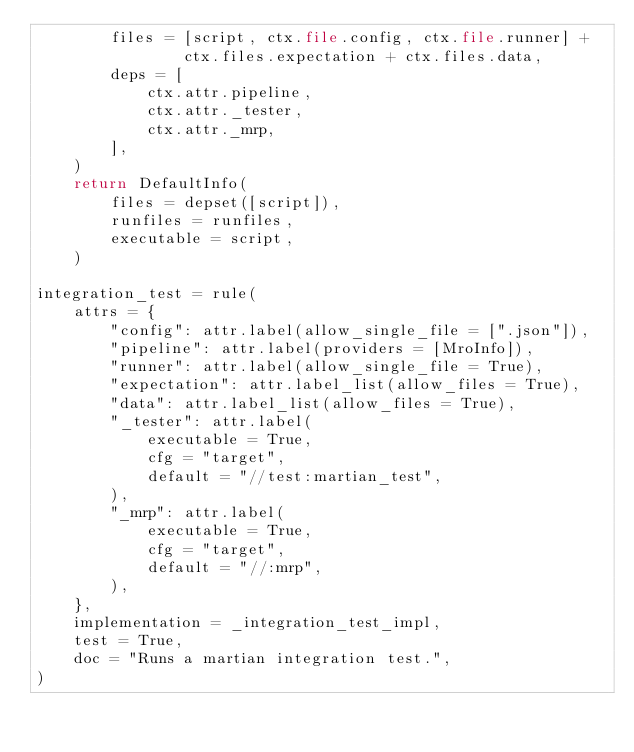<code> <loc_0><loc_0><loc_500><loc_500><_Python_>        files = [script, ctx.file.config, ctx.file.runner] +
                ctx.files.expectation + ctx.files.data,
        deps = [
            ctx.attr.pipeline,
            ctx.attr._tester,
            ctx.attr._mrp,
        ],
    )
    return DefaultInfo(
        files = depset([script]),
        runfiles = runfiles,
        executable = script,
    )

integration_test = rule(
    attrs = {
        "config": attr.label(allow_single_file = [".json"]),
        "pipeline": attr.label(providers = [MroInfo]),
        "runner": attr.label(allow_single_file = True),
        "expectation": attr.label_list(allow_files = True),
        "data": attr.label_list(allow_files = True),
        "_tester": attr.label(
            executable = True,
            cfg = "target",
            default = "//test:martian_test",
        ),
        "_mrp": attr.label(
            executable = True,
            cfg = "target",
            default = "//:mrp",
        ),
    },
    implementation = _integration_test_impl,
    test = True,
    doc = "Runs a martian integration test.",
)
</code> 